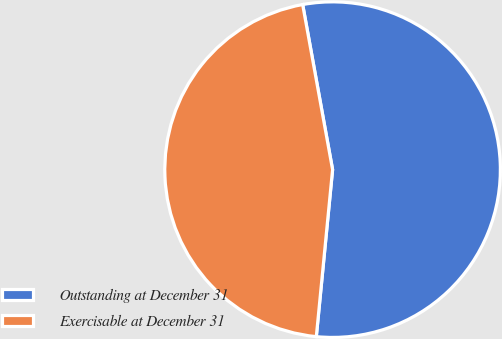<chart> <loc_0><loc_0><loc_500><loc_500><pie_chart><fcel>Outstanding at December 31<fcel>Exercisable at December 31<nl><fcel>54.4%<fcel>45.6%<nl></chart> 